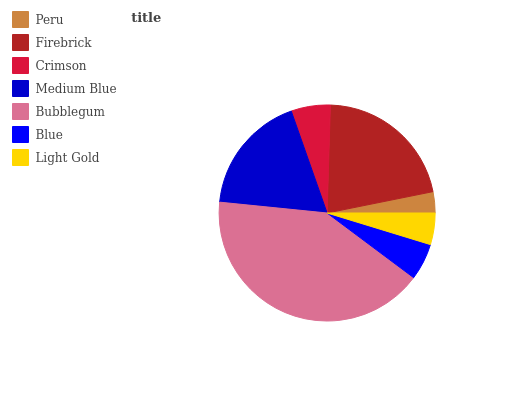Is Peru the minimum?
Answer yes or no. Yes. Is Bubblegum the maximum?
Answer yes or no. Yes. Is Firebrick the minimum?
Answer yes or no. No. Is Firebrick the maximum?
Answer yes or no. No. Is Firebrick greater than Peru?
Answer yes or no. Yes. Is Peru less than Firebrick?
Answer yes or no. Yes. Is Peru greater than Firebrick?
Answer yes or no. No. Is Firebrick less than Peru?
Answer yes or no. No. Is Crimson the high median?
Answer yes or no. Yes. Is Crimson the low median?
Answer yes or no. Yes. Is Medium Blue the high median?
Answer yes or no. No. Is Firebrick the low median?
Answer yes or no. No. 